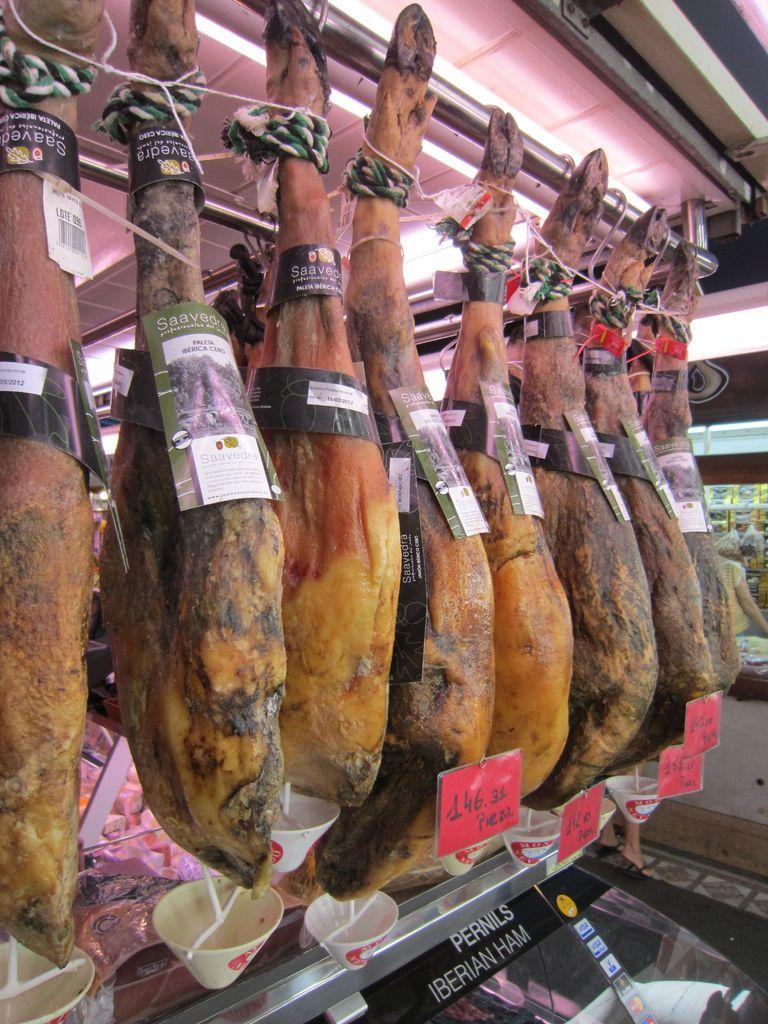What type of body parts are visible in the image? There are animal legs in the image. How are the animal legs positioned in the image? The animal legs are hanged to an iron rod with ropes. Are there any indications of the price of the animal legs in the image? Yes, price tags are attached to the animal legs. What other items can be seen in the image besides the animal legs? There are bowls and other objects in the image. Is there a person present in the image? Yes, a person is standing in the image. What type of coast can be seen in the image? There is no coast present in the image; it features animal legs hanging from an iron rod. 